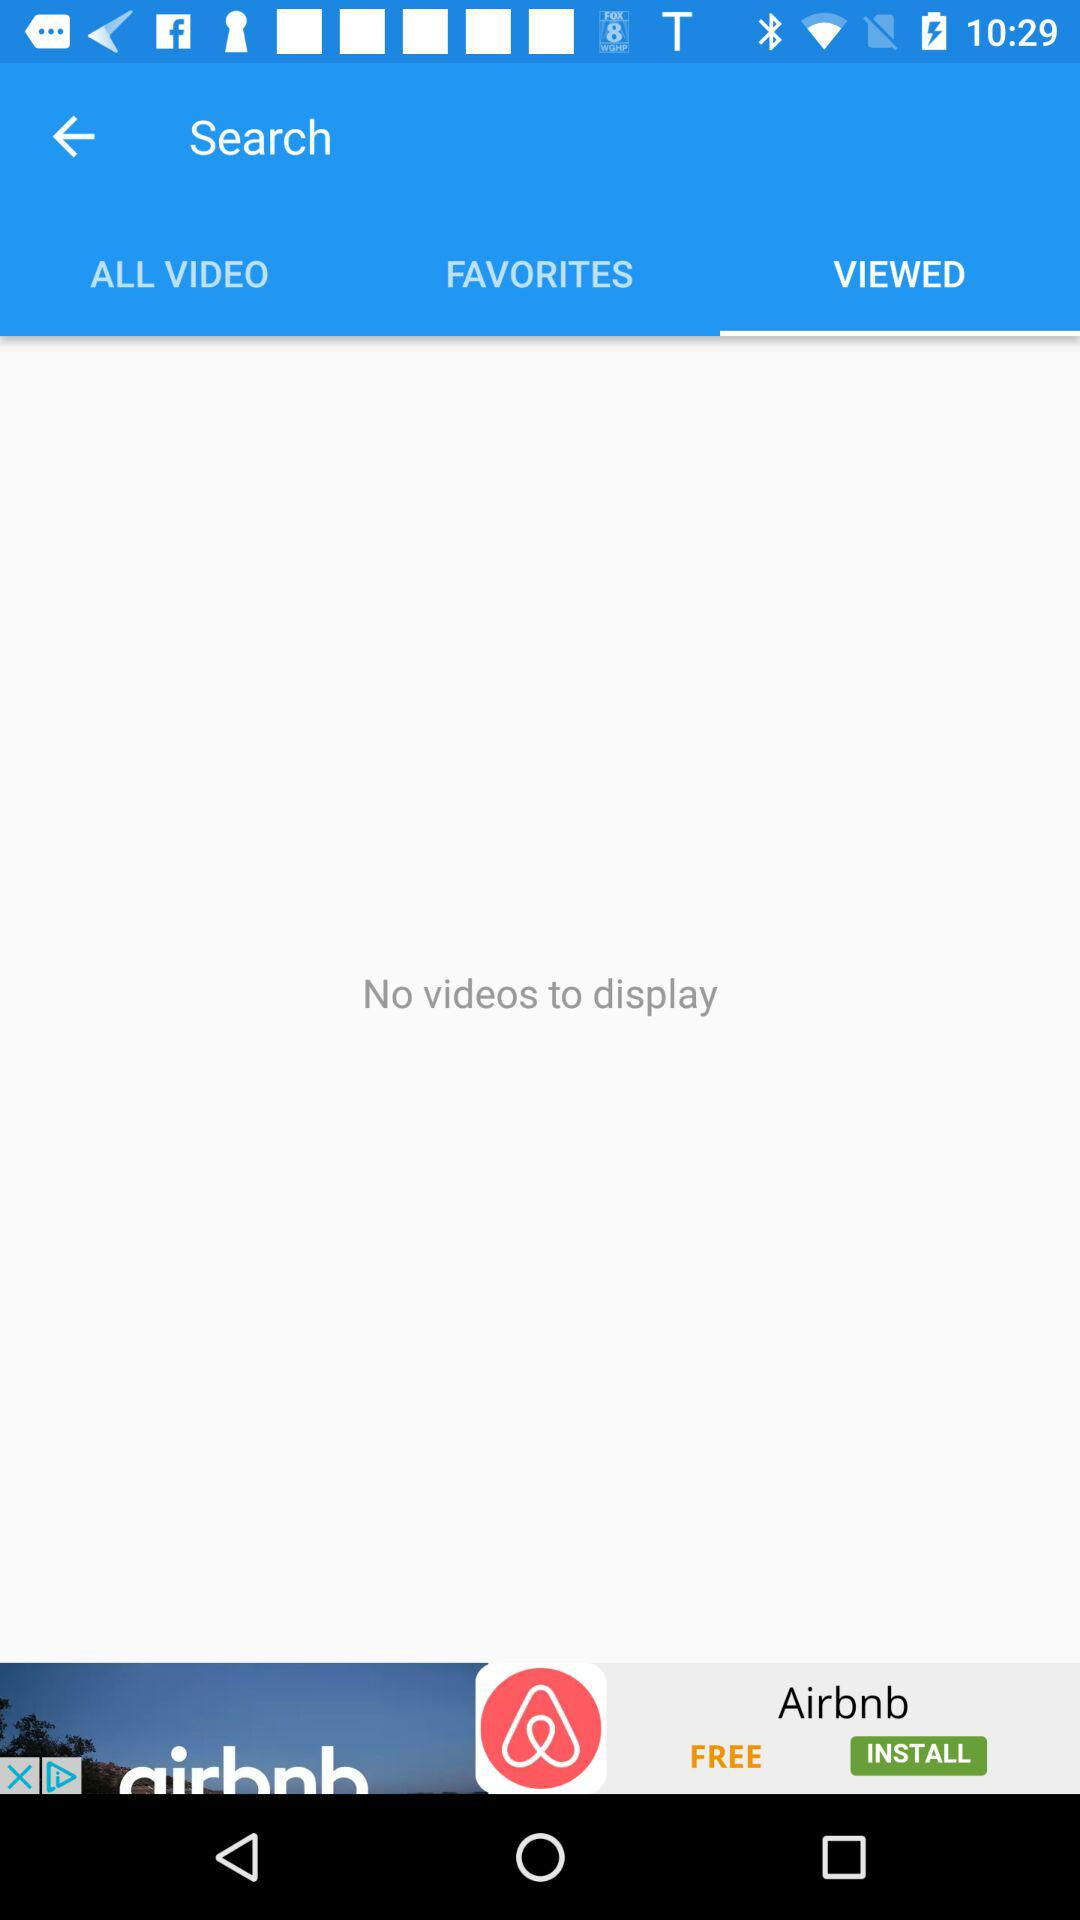What tab has been selected? The selected tab is "VIEWED". 